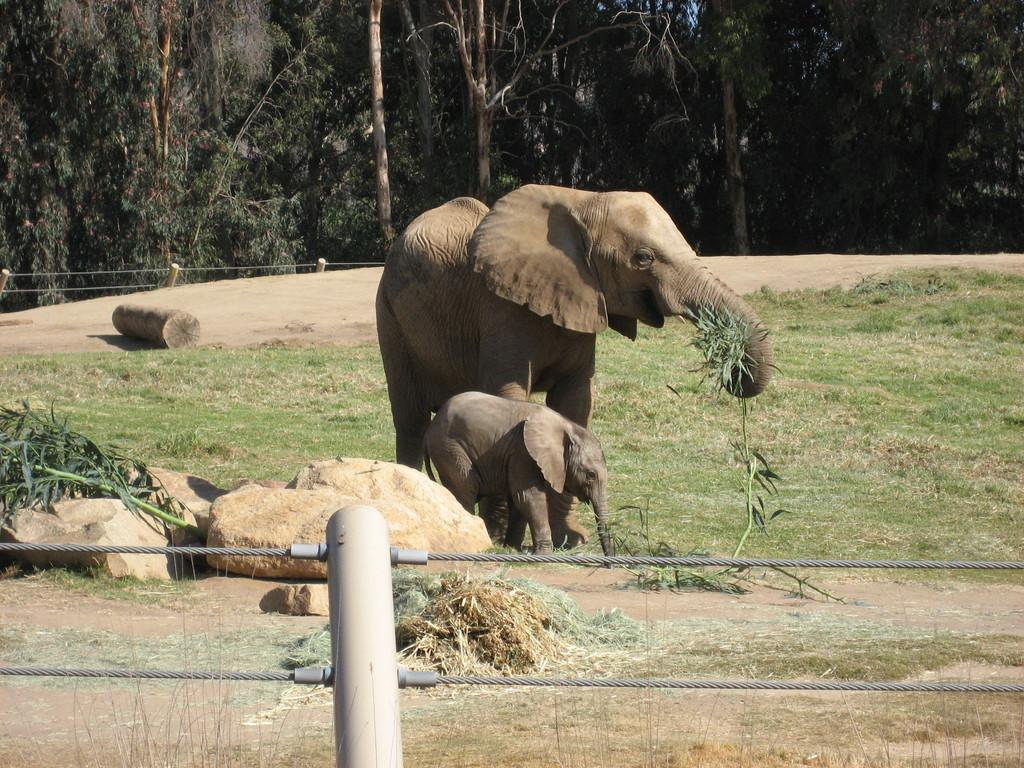What type of natural elements can be seen in the image? There are rocks and grass visible in the image. What man-made object can be seen in the image? There is a wooden log and a fence in the image. What animals are present in the image? There is an elephant and a baby elephant in the image. What can be seen in the background of the image? There are trees in the background of the image. What type of rhythm can be heard from the eggs in the image? There are no eggs present in the image, so there is no rhythm to be heard. Can you describe the tiger's stripes in the image? There is no tiger present in the image, so there are no stripes to describe. 